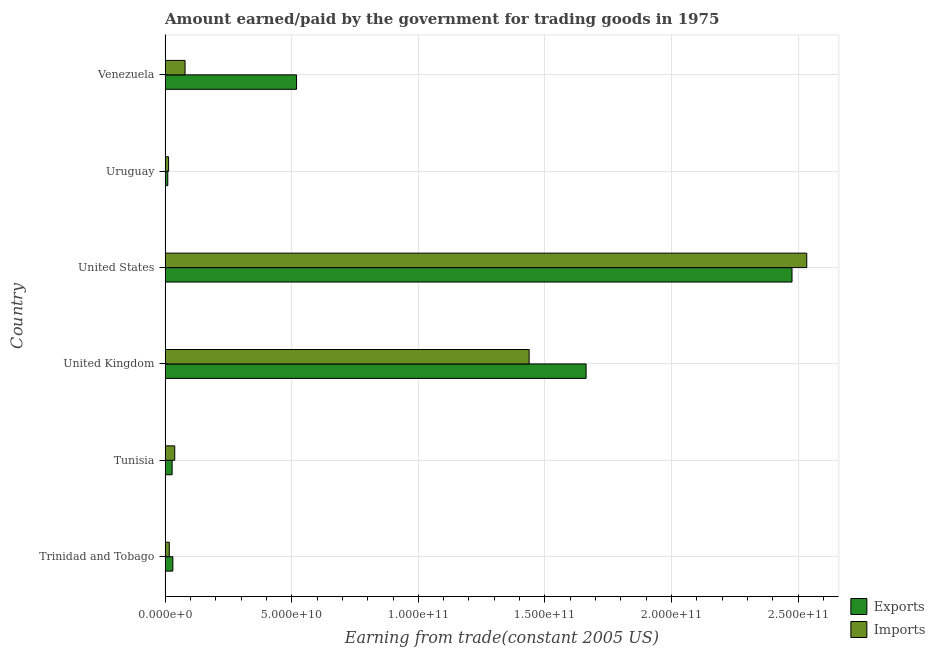How many groups of bars are there?
Your answer should be very brief. 6. Are the number of bars per tick equal to the number of legend labels?
Give a very brief answer. Yes. How many bars are there on the 6th tick from the bottom?
Offer a terse response. 2. What is the label of the 2nd group of bars from the top?
Offer a terse response. Uruguay. What is the amount paid for imports in Tunisia?
Keep it short and to the point. 3.81e+09. Across all countries, what is the maximum amount paid for imports?
Make the answer very short. 2.53e+11. Across all countries, what is the minimum amount paid for imports?
Your answer should be compact. 1.38e+09. In which country was the amount paid for imports maximum?
Make the answer very short. United States. In which country was the amount paid for imports minimum?
Your answer should be compact. Uruguay. What is the total amount earned from exports in the graph?
Keep it short and to the point. 4.73e+11. What is the difference between the amount paid for imports in United Kingdom and that in United States?
Provide a succinct answer. -1.10e+11. What is the difference between the amount earned from exports in Uruguay and the amount paid for imports in Tunisia?
Keep it short and to the point. -2.75e+09. What is the average amount paid for imports per country?
Offer a terse response. 6.86e+1. What is the difference between the amount paid for imports and amount earned from exports in United Kingdom?
Provide a short and direct response. -2.25e+1. What is the ratio of the amount paid for imports in Trinidad and Tobago to that in United States?
Offer a terse response. 0.01. Is the difference between the amount paid for imports in United Kingdom and United States greater than the difference between the amount earned from exports in United Kingdom and United States?
Give a very brief answer. No. What is the difference between the highest and the second highest amount earned from exports?
Keep it short and to the point. 8.13e+1. What is the difference between the highest and the lowest amount paid for imports?
Keep it short and to the point. 2.52e+11. In how many countries, is the amount earned from exports greater than the average amount earned from exports taken over all countries?
Make the answer very short. 2. Is the sum of the amount earned from exports in Trinidad and Tobago and United States greater than the maximum amount paid for imports across all countries?
Ensure brevity in your answer.  No. What does the 1st bar from the top in United Kingdom represents?
Your answer should be very brief. Imports. What does the 1st bar from the bottom in Venezuela represents?
Offer a very short reply. Exports. Are all the bars in the graph horizontal?
Make the answer very short. Yes. Are the values on the major ticks of X-axis written in scientific E-notation?
Offer a very short reply. Yes. Does the graph contain any zero values?
Offer a very short reply. No. Does the graph contain grids?
Provide a succinct answer. Yes. How are the legend labels stacked?
Provide a short and direct response. Vertical. What is the title of the graph?
Your response must be concise. Amount earned/paid by the government for trading goods in 1975. What is the label or title of the X-axis?
Offer a terse response. Earning from trade(constant 2005 US). What is the Earning from trade(constant 2005 US) of Exports in Trinidad and Tobago?
Your response must be concise. 3.06e+09. What is the Earning from trade(constant 2005 US) in Imports in Trinidad and Tobago?
Keep it short and to the point. 1.66e+09. What is the Earning from trade(constant 2005 US) of Exports in Tunisia?
Provide a short and direct response. 2.78e+09. What is the Earning from trade(constant 2005 US) of Imports in Tunisia?
Give a very brief answer. 3.81e+09. What is the Earning from trade(constant 2005 US) of Exports in United Kingdom?
Your answer should be very brief. 1.66e+11. What is the Earning from trade(constant 2005 US) in Imports in United Kingdom?
Your answer should be compact. 1.44e+11. What is the Earning from trade(constant 2005 US) of Exports in United States?
Offer a terse response. 2.48e+11. What is the Earning from trade(constant 2005 US) in Imports in United States?
Give a very brief answer. 2.53e+11. What is the Earning from trade(constant 2005 US) of Exports in Uruguay?
Make the answer very short. 1.06e+09. What is the Earning from trade(constant 2005 US) in Imports in Uruguay?
Provide a succinct answer. 1.38e+09. What is the Earning from trade(constant 2005 US) of Exports in Venezuela?
Your response must be concise. 5.19e+1. What is the Earning from trade(constant 2005 US) of Imports in Venezuela?
Your response must be concise. 7.88e+09. Across all countries, what is the maximum Earning from trade(constant 2005 US) in Exports?
Provide a short and direct response. 2.48e+11. Across all countries, what is the maximum Earning from trade(constant 2005 US) of Imports?
Make the answer very short. 2.53e+11. Across all countries, what is the minimum Earning from trade(constant 2005 US) of Exports?
Ensure brevity in your answer.  1.06e+09. Across all countries, what is the minimum Earning from trade(constant 2005 US) in Imports?
Your answer should be very brief. 1.38e+09. What is the total Earning from trade(constant 2005 US) in Exports in the graph?
Ensure brevity in your answer.  4.73e+11. What is the total Earning from trade(constant 2005 US) of Imports in the graph?
Offer a terse response. 4.12e+11. What is the difference between the Earning from trade(constant 2005 US) in Exports in Trinidad and Tobago and that in Tunisia?
Keep it short and to the point. 2.85e+08. What is the difference between the Earning from trade(constant 2005 US) in Imports in Trinidad and Tobago and that in Tunisia?
Keep it short and to the point. -2.15e+09. What is the difference between the Earning from trade(constant 2005 US) of Exports in Trinidad and Tobago and that in United Kingdom?
Your response must be concise. -1.63e+11. What is the difference between the Earning from trade(constant 2005 US) of Imports in Trinidad and Tobago and that in United Kingdom?
Your answer should be very brief. -1.42e+11. What is the difference between the Earning from trade(constant 2005 US) of Exports in Trinidad and Tobago and that in United States?
Provide a short and direct response. -2.45e+11. What is the difference between the Earning from trade(constant 2005 US) of Imports in Trinidad and Tobago and that in United States?
Provide a short and direct response. -2.52e+11. What is the difference between the Earning from trade(constant 2005 US) in Exports in Trinidad and Tobago and that in Uruguay?
Give a very brief answer. 2.00e+09. What is the difference between the Earning from trade(constant 2005 US) in Imports in Trinidad and Tobago and that in Uruguay?
Give a very brief answer. 2.77e+08. What is the difference between the Earning from trade(constant 2005 US) of Exports in Trinidad and Tobago and that in Venezuela?
Ensure brevity in your answer.  -4.88e+1. What is the difference between the Earning from trade(constant 2005 US) in Imports in Trinidad and Tobago and that in Venezuela?
Your response must be concise. -6.23e+09. What is the difference between the Earning from trade(constant 2005 US) of Exports in Tunisia and that in United Kingdom?
Provide a succinct answer. -1.63e+11. What is the difference between the Earning from trade(constant 2005 US) in Imports in Tunisia and that in United Kingdom?
Provide a short and direct response. -1.40e+11. What is the difference between the Earning from trade(constant 2005 US) of Exports in Tunisia and that in United States?
Make the answer very short. -2.45e+11. What is the difference between the Earning from trade(constant 2005 US) of Imports in Tunisia and that in United States?
Offer a terse response. -2.50e+11. What is the difference between the Earning from trade(constant 2005 US) in Exports in Tunisia and that in Uruguay?
Provide a short and direct response. 1.72e+09. What is the difference between the Earning from trade(constant 2005 US) in Imports in Tunisia and that in Uruguay?
Provide a short and direct response. 2.43e+09. What is the difference between the Earning from trade(constant 2005 US) in Exports in Tunisia and that in Venezuela?
Make the answer very short. -4.91e+1. What is the difference between the Earning from trade(constant 2005 US) in Imports in Tunisia and that in Venezuela?
Your answer should be very brief. -4.08e+09. What is the difference between the Earning from trade(constant 2005 US) of Exports in United Kingdom and that in United States?
Provide a short and direct response. -8.13e+1. What is the difference between the Earning from trade(constant 2005 US) in Imports in United Kingdom and that in United States?
Your answer should be compact. -1.10e+11. What is the difference between the Earning from trade(constant 2005 US) in Exports in United Kingdom and that in Uruguay?
Your answer should be very brief. 1.65e+11. What is the difference between the Earning from trade(constant 2005 US) in Imports in United Kingdom and that in Uruguay?
Provide a succinct answer. 1.42e+11. What is the difference between the Earning from trade(constant 2005 US) in Exports in United Kingdom and that in Venezuela?
Your answer should be compact. 1.14e+11. What is the difference between the Earning from trade(constant 2005 US) in Imports in United Kingdom and that in Venezuela?
Provide a short and direct response. 1.36e+11. What is the difference between the Earning from trade(constant 2005 US) in Exports in United States and that in Uruguay?
Provide a succinct answer. 2.47e+11. What is the difference between the Earning from trade(constant 2005 US) of Imports in United States and that in Uruguay?
Give a very brief answer. 2.52e+11. What is the difference between the Earning from trade(constant 2005 US) in Exports in United States and that in Venezuela?
Your answer should be compact. 1.96e+11. What is the difference between the Earning from trade(constant 2005 US) in Imports in United States and that in Venezuela?
Provide a short and direct response. 2.46e+11. What is the difference between the Earning from trade(constant 2005 US) of Exports in Uruguay and that in Venezuela?
Keep it short and to the point. -5.08e+1. What is the difference between the Earning from trade(constant 2005 US) of Imports in Uruguay and that in Venezuela?
Offer a terse response. -6.50e+09. What is the difference between the Earning from trade(constant 2005 US) in Exports in Trinidad and Tobago and the Earning from trade(constant 2005 US) in Imports in Tunisia?
Your response must be concise. -7.43e+08. What is the difference between the Earning from trade(constant 2005 US) in Exports in Trinidad and Tobago and the Earning from trade(constant 2005 US) in Imports in United Kingdom?
Make the answer very short. -1.41e+11. What is the difference between the Earning from trade(constant 2005 US) in Exports in Trinidad and Tobago and the Earning from trade(constant 2005 US) in Imports in United States?
Provide a succinct answer. -2.50e+11. What is the difference between the Earning from trade(constant 2005 US) in Exports in Trinidad and Tobago and the Earning from trade(constant 2005 US) in Imports in Uruguay?
Offer a very short reply. 1.68e+09. What is the difference between the Earning from trade(constant 2005 US) of Exports in Trinidad and Tobago and the Earning from trade(constant 2005 US) of Imports in Venezuela?
Your response must be concise. -4.82e+09. What is the difference between the Earning from trade(constant 2005 US) of Exports in Tunisia and the Earning from trade(constant 2005 US) of Imports in United Kingdom?
Ensure brevity in your answer.  -1.41e+11. What is the difference between the Earning from trade(constant 2005 US) of Exports in Tunisia and the Earning from trade(constant 2005 US) of Imports in United States?
Ensure brevity in your answer.  -2.51e+11. What is the difference between the Earning from trade(constant 2005 US) in Exports in Tunisia and the Earning from trade(constant 2005 US) in Imports in Uruguay?
Your answer should be compact. 1.40e+09. What is the difference between the Earning from trade(constant 2005 US) of Exports in Tunisia and the Earning from trade(constant 2005 US) of Imports in Venezuela?
Offer a very short reply. -5.10e+09. What is the difference between the Earning from trade(constant 2005 US) of Exports in United Kingdom and the Earning from trade(constant 2005 US) of Imports in United States?
Make the answer very short. -8.71e+1. What is the difference between the Earning from trade(constant 2005 US) of Exports in United Kingdom and the Earning from trade(constant 2005 US) of Imports in Uruguay?
Offer a terse response. 1.65e+11. What is the difference between the Earning from trade(constant 2005 US) in Exports in United Kingdom and the Earning from trade(constant 2005 US) in Imports in Venezuela?
Give a very brief answer. 1.58e+11. What is the difference between the Earning from trade(constant 2005 US) of Exports in United States and the Earning from trade(constant 2005 US) of Imports in Uruguay?
Your answer should be compact. 2.46e+11. What is the difference between the Earning from trade(constant 2005 US) in Exports in United States and the Earning from trade(constant 2005 US) in Imports in Venezuela?
Your answer should be very brief. 2.40e+11. What is the difference between the Earning from trade(constant 2005 US) in Exports in Uruguay and the Earning from trade(constant 2005 US) in Imports in Venezuela?
Offer a very short reply. -6.82e+09. What is the average Earning from trade(constant 2005 US) in Exports per country?
Offer a terse response. 7.88e+1. What is the average Earning from trade(constant 2005 US) of Imports per country?
Provide a short and direct response. 6.86e+1. What is the difference between the Earning from trade(constant 2005 US) of Exports and Earning from trade(constant 2005 US) of Imports in Trinidad and Tobago?
Offer a very short reply. 1.41e+09. What is the difference between the Earning from trade(constant 2005 US) of Exports and Earning from trade(constant 2005 US) of Imports in Tunisia?
Give a very brief answer. -1.03e+09. What is the difference between the Earning from trade(constant 2005 US) of Exports and Earning from trade(constant 2005 US) of Imports in United Kingdom?
Give a very brief answer. 2.25e+1. What is the difference between the Earning from trade(constant 2005 US) of Exports and Earning from trade(constant 2005 US) of Imports in United States?
Give a very brief answer. -5.82e+09. What is the difference between the Earning from trade(constant 2005 US) in Exports and Earning from trade(constant 2005 US) in Imports in Uruguay?
Offer a terse response. -3.21e+08. What is the difference between the Earning from trade(constant 2005 US) in Exports and Earning from trade(constant 2005 US) in Imports in Venezuela?
Provide a succinct answer. 4.40e+1. What is the ratio of the Earning from trade(constant 2005 US) of Exports in Trinidad and Tobago to that in Tunisia?
Your response must be concise. 1.1. What is the ratio of the Earning from trade(constant 2005 US) of Imports in Trinidad and Tobago to that in Tunisia?
Offer a very short reply. 0.44. What is the ratio of the Earning from trade(constant 2005 US) in Exports in Trinidad and Tobago to that in United Kingdom?
Your answer should be compact. 0.02. What is the ratio of the Earning from trade(constant 2005 US) in Imports in Trinidad and Tobago to that in United Kingdom?
Make the answer very short. 0.01. What is the ratio of the Earning from trade(constant 2005 US) of Exports in Trinidad and Tobago to that in United States?
Offer a very short reply. 0.01. What is the ratio of the Earning from trade(constant 2005 US) of Imports in Trinidad and Tobago to that in United States?
Your response must be concise. 0.01. What is the ratio of the Earning from trade(constant 2005 US) of Exports in Trinidad and Tobago to that in Uruguay?
Your answer should be very brief. 2.89. What is the ratio of the Earning from trade(constant 2005 US) in Imports in Trinidad and Tobago to that in Uruguay?
Offer a very short reply. 1.2. What is the ratio of the Earning from trade(constant 2005 US) in Exports in Trinidad and Tobago to that in Venezuela?
Your response must be concise. 0.06. What is the ratio of the Earning from trade(constant 2005 US) of Imports in Trinidad and Tobago to that in Venezuela?
Keep it short and to the point. 0.21. What is the ratio of the Earning from trade(constant 2005 US) of Exports in Tunisia to that in United Kingdom?
Offer a very short reply. 0.02. What is the ratio of the Earning from trade(constant 2005 US) of Imports in Tunisia to that in United Kingdom?
Make the answer very short. 0.03. What is the ratio of the Earning from trade(constant 2005 US) of Exports in Tunisia to that in United States?
Provide a short and direct response. 0.01. What is the ratio of the Earning from trade(constant 2005 US) of Imports in Tunisia to that in United States?
Your answer should be compact. 0.01. What is the ratio of the Earning from trade(constant 2005 US) of Exports in Tunisia to that in Uruguay?
Keep it short and to the point. 2.63. What is the ratio of the Earning from trade(constant 2005 US) of Imports in Tunisia to that in Uruguay?
Give a very brief answer. 2.76. What is the ratio of the Earning from trade(constant 2005 US) of Exports in Tunisia to that in Venezuela?
Make the answer very short. 0.05. What is the ratio of the Earning from trade(constant 2005 US) in Imports in Tunisia to that in Venezuela?
Offer a terse response. 0.48. What is the ratio of the Earning from trade(constant 2005 US) in Exports in United Kingdom to that in United States?
Your answer should be very brief. 0.67. What is the ratio of the Earning from trade(constant 2005 US) of Imports in United Kingdom to that in United States?
Give a very brief answer. 0.57. What is the ratio of the Earning from trade(constant 2005 US) in Exports in United Kingdom to that in Uruguay?
Your response must be concise. 157.13. What is the ratio of the Earning from trade(constant 2005 US) in Imports in United Kingdom to that in Uruguay?
Make the answer very short. 104.25. What is the ratio of the Earning from trade(constant 2005 US) in Exports in United Kingdom to that in Venezuela?
Keep it short and to the point. 3.2. What is the ratio of the Earning from trade(constant 2005 US) in Imports in United Kingdom to that in Venezuela?
Make the answer very short. 18.24. What is the ratio of the Earning from trade(constant 2005 US) of Exports in United States to that in Uruguay?
Your answer should be compact. 233.99. What is the ratio of the Earning from trade(constant 2005 US) of Imports in United States to that in Uruguay?
Keep it short and to the point. 183.74. What is the ratio of the Earning from trade(constant 2005 US) in Exports in United States to that in Venezuela?
Provide a short and direct response. 4.77. What is the ratio of the Earning from trade(constant 2005 US) in Imports in United States to that in Venezuela?
Your response must be concise. 32.15. What is the ratio of the Earning from trade(constant 2005 US) in Exports in Uruguay to that in Venezuela?
Give a very brief answer. 0.02. What is the ratio of the Earning from trade(constant 2005 US) of Imports in Uruguay to that in Venezuela?
Make the answer very short. 0.17. What is the difference between the highest and the second highest Earning from trade(constant 2005 US) of Exports?
Ensure brevity in your answer.  8.13e+1. What is the difference between the highest and the second highest Earning from trade(constant 2005 US) of Imports?
Your answer should be very brief. 1.10e+11. What is the difference between the highest and the lowest Earning from trade(constant 2005 US) in Exports?
Your response must be concise. 2.47e+11. What is the difference between the highest and the lowest Earning from trade(constant 2005 US) in Imports?
Give a very brief answer. 2.52e+11. 